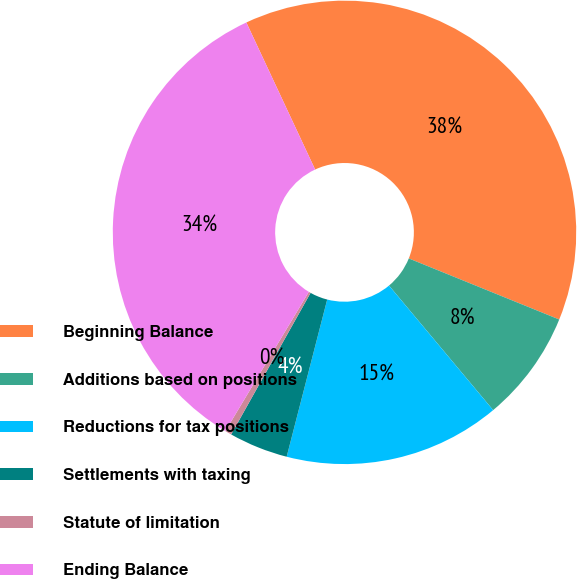<chart> <loc_0><loc_0><loc_500><loc_500><pie_chart><fcel>Beginning Balance<fcel>Additions based on positions<fcel>Reductions for tax positions<fcel>Settlements with taxing<fcel>Statute of limitation<fcel>Ending Balance<nl><fcel>38.1%<fcel>7.78%<fcel>15.1%<fcel>4.12%<fcel>0.46%<fcel>34.44%<nl></chart> 